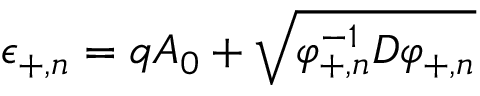<formula> <loc_0><loc_0><loc_500><loc_500>\epsilon _ { + , n } = q A _ { 0 } + \sqrt { \varphi _ { + , n } ^ { - 1 } D \varphi _ { + , n } }</formula> 